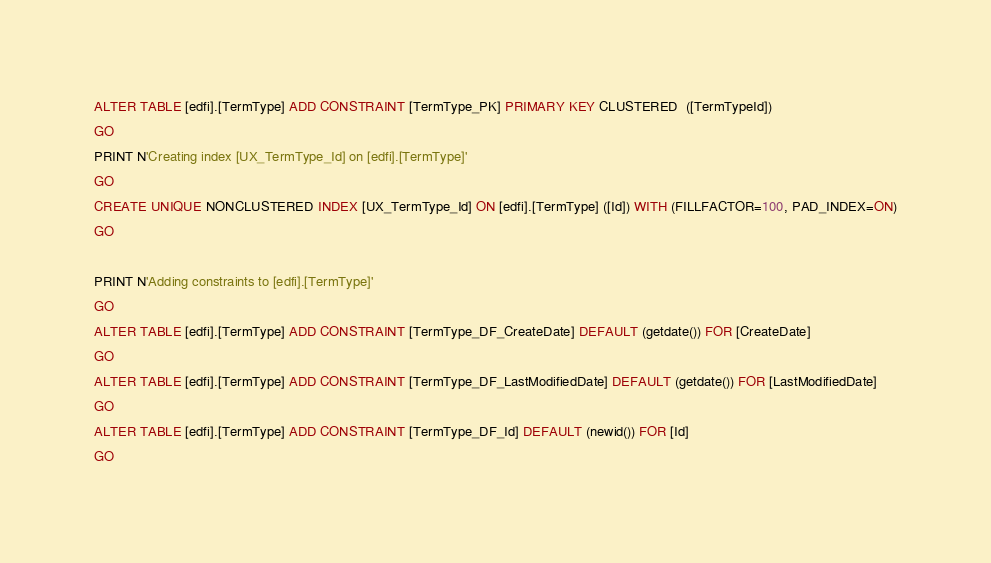<code> <loc_0><loc_0><loc_500><loc_500><_SQL_>ALTER TABLE [edfi].[TermType] ADD CONSTRAINT [TermType_PK] PRIMARY KEY CLUSTERED  ([TermTypeId])
GO
PRINT N'Creating index [UX_TermType_Id] on [edfi].[TermType]'
GO
CREATE UNIQUE NONCLUSTERED INDEX [UX_TermType_Id] ON [edfi].[TermType] ([Id]) WITH (FILLFACTOR=100, PAD_INDEX=ON)
GO

PRINT N'Adding constraints to [edfi].[TermType]'
GO
ALTER TABLE [edfi].[TermType] ADD CONSTRAINT [TermType_DF_CreateDate] DEFAULT (getdate()) FOR [CreateDate]
GO
ALTER TABLE [edfi].[TermType] ADD CONSTRAINT [TermType_DF_LastModifiedDate] DEFAULT (getdate()) FOR [LastModifiedDate]
GO
ALTER TABLE [edfi].[TermType] ADD CONSTRAINT [TermType_DF_Id] DEFAULT (newid()) FOR [Id]
GO

</code> 